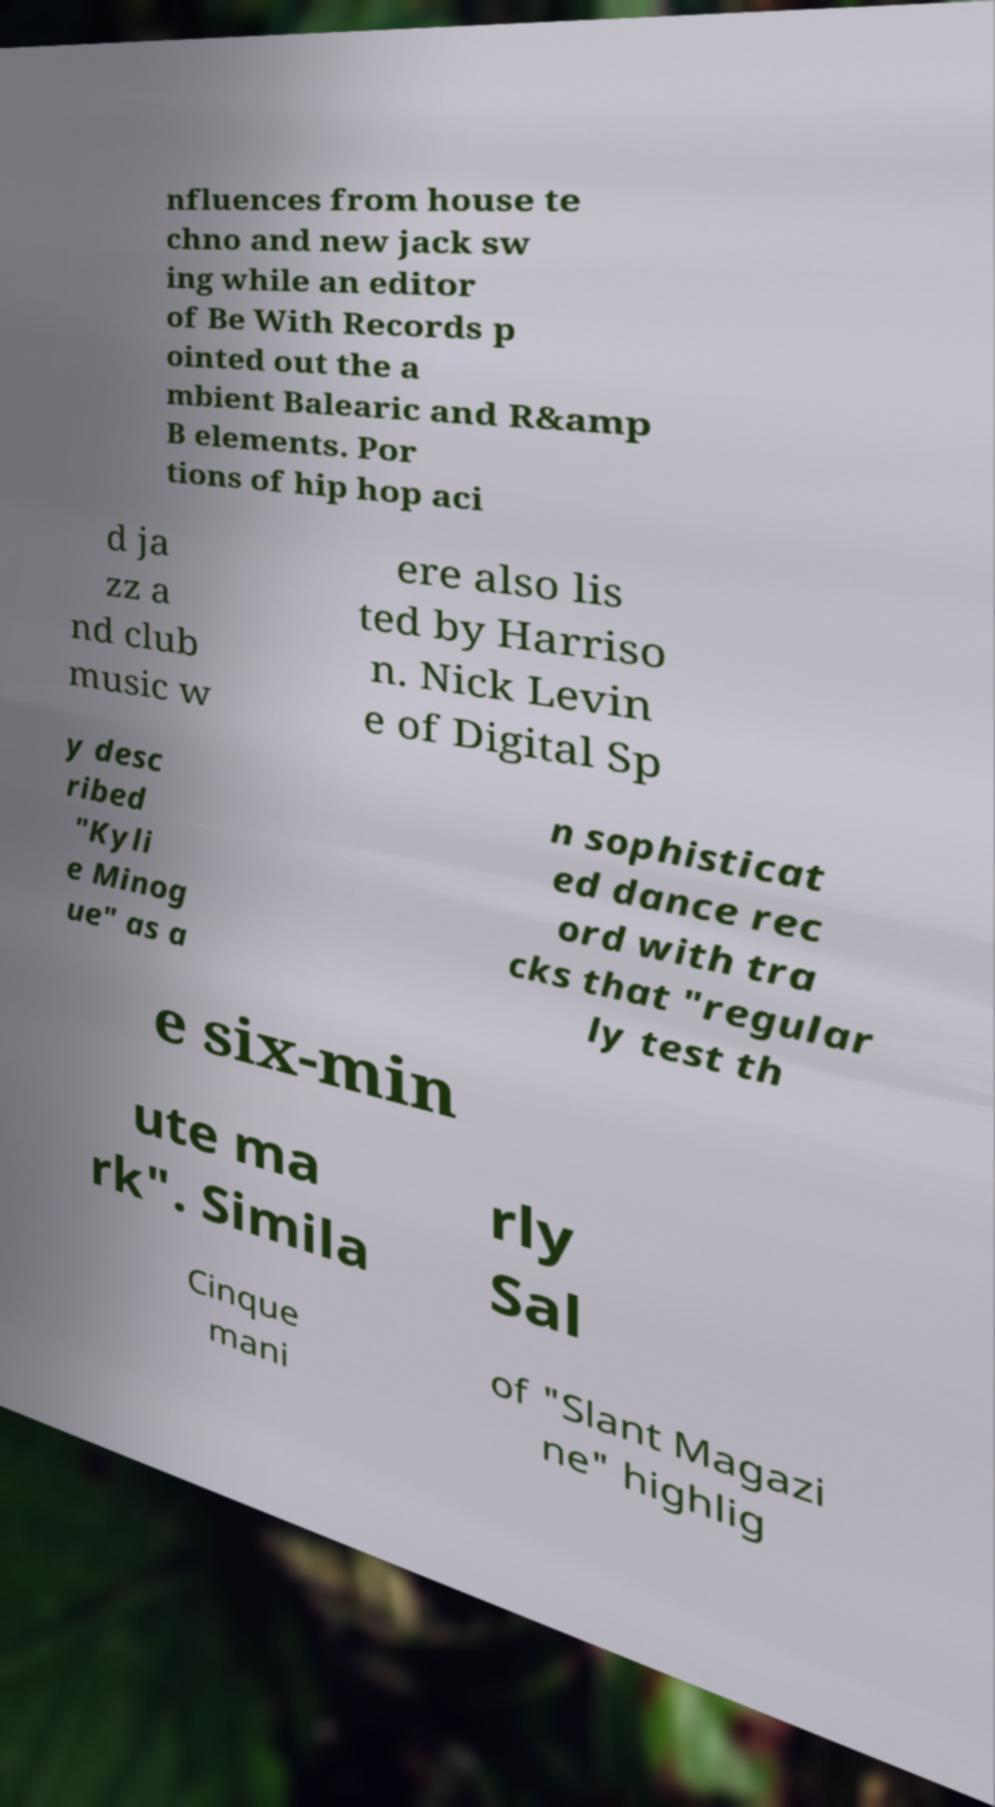Can you accurately transcribe the text from the provided image for me? nfluences from house te chno and new jack sw ing while an editor of Be With Records p ointed out the a mbient Balearic and R&amp B elements. Por tions of hip hop aci d ja zz a nd club music w ere also lis ted by Harriso n. Nick Levin e of Digital Sp y desc ribed "Kyli e Minog ue" as a n sophisticat ed dance rec ord with tra cks that "regular ly test th e six-min ute ma rk". Simila rly Sal Cinque mani of "Slant Magazi ne" highlig 